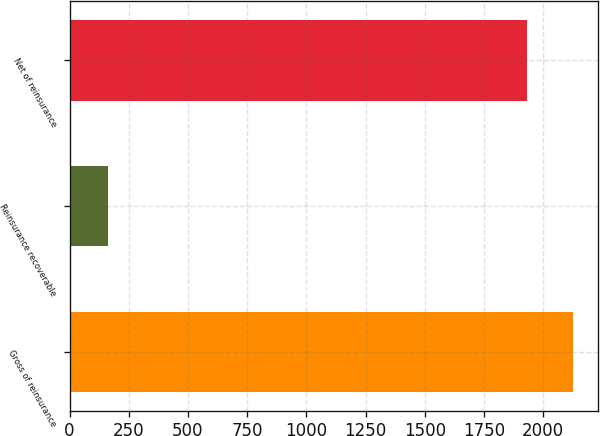<chart> <loc_0><loc_0><loc_500><loc_500><bar_chart><fcel>Gross of reinsurance<fcel>Reinsurance recoverable<fcel>Net of reinsurance<nl><fcel>2125.2<fcel>161<fcel>1932<nl></chart> 